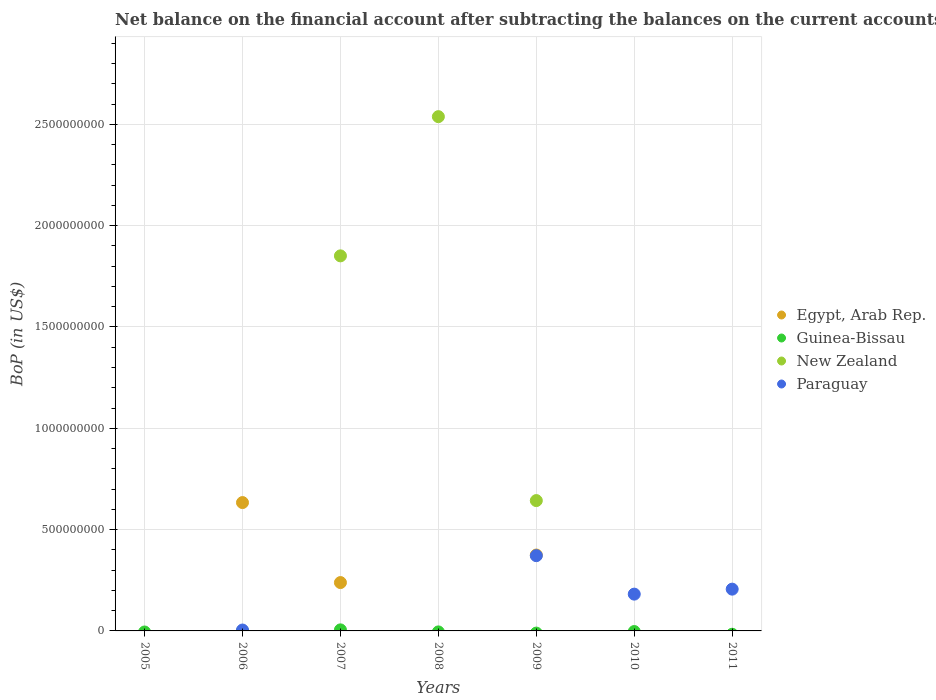Across all years, what is the maximum Balance of Payments in New Zealand?
Your answer should be very brief. 2.54e+09. Across all years, what is the minimum Balance of Payments in New Zealand?
Ensure brevity in your answer.  0. What is the total Balance of Payments in New Zealand in the graph?
Give a very brief answer. 5.03e+09. What is the difference between the Balance of Payments in Paraguay in 2006 and that in 2011?
Your answer should be compact. -2.02e+08. What is the difference between the Balance of Payments in Egypt, Arab Rep. in 2009 and the Balance of Payments in Paraguay in 2008?
Provide a short and direct response. 3.75e+08. What is the average Balance of Payments in New Zealand per year?
Make the answer very short. 7.19e+08. In the year 2007, what is the difference between the Balance of Payments in New Zealand and Balance of Payments in Guinea-Bissau?
Make the answer very short. 1.85e+09. In how many years, is the Balance of Payments in Paraguay greater than 2500000000 US$?
Ensure brevity in your answer.  0. What is the ratio of the Balance of Payments in Paraguay in 2009 to that in 2011?
Offer a terse response. 1.8. Is the Balance of Payments in Paraguay in 2010 less than that in 2011?
Provide a succinct answer. Yes. What is the difference between the highest and the second highest Balance of Payments in New Zealand?
Offer a terse response. 6.87e+08. What is the difference between the highest and the lowest Balance of Payments in Egypt, Arab Rep.?
Provide a short and direct response. 6.33e+08. Is it the case that in every year, the sum of the Balance of Payments in New Zealand and Balance of Payments in Egypt, Arab Rep.  is greater than the sum of Balance of Payments in Guinea-Bissau and Balance of Payments in Paraguay?
Your response must be concise. No. Is the Balance of Payments in New Zealand strictly less than the Balance of Payments in Paraguay over the years?
Keep it short and to the point. No. How many dotlines are there?
Keep it short and to the point. 4. How many years are there in the graph?
Offer a terse response. 7. Does the graph contain any zero values?
Offer a very short reply. Yes. How many legend labels are there?
Offer a terse response. 4. What is the title of the graph?
Make the answer very short. Net balance on the financial account after subtracting the balances on the current accounts. What is the label or title of the Y-axis?
Give a very brief answer. BoP (in US$). What is the BoP (in US$) in Egypt, Arab Rep. in 2006?
Offer a terse response. 6.33e+08. What is the BoP (in US$) of Paraguay in 2006?
Keep it short and to the point. 4.40e+06. What is the BoP (in US$) in Egypt, Arab Rep. in 2007?
Ensure brevity in your answer.  2.39e+08. What is the BoP (in US$) of Guinea-Bissau in 2007?
Keep it short and to the point. 5.20e+06. What is the BoP (in US$) of New Zealand in 2007?
Ensure brevity in your answer.  1.85e+09. What is the BoP (in US$) of Guinea-Bissau in 2008?
Offer a terse response. 0. What is the BoP (in US$) in New Zealand in 2008?
Provide a short and direct response. 2.54e+09. What is the BoP (in US$) of Egypt, Arab Rep. in 2009?
Your response must be concise. 3.75e+08. What is the BoP (in US$) in New Zealand in 2009?
Ensure brevity in your answer.  6.43e+08. What is the BoP (in US$) in Paraguay in 2009?
Provide a succinct answer. 3.71e+08. What is the BoP (in US$) in Guinea-Bissau in 2010?
Provide a short and direct response. 0. What is the BoP (in US$) in New Zealand in 2010?
Offer a very short reply. 0. What is the BoP (in US$) of Paraguay in 2010?
Your answer should be very brief. 1.82e+08. What is the BoP (in US$) of Egypt, Arab Rep. in 2011?
Offer a terse response. 0. What is the BoP (in US$) in Guinea-Bissau in 2011?
Offer a terse response. 0. What is the BoP (in US$) of Paraguay in 2011?
Offer a very short reply. 2.06e+08. Across all years, what is the maximum BoP (in US$) in Egypt, Arab Rep.?
Offer a terse response. 6.33e+08. Across all years, what is the maximum BoP (in US$) in Guinea-Bissau?
Your response must be concise. 5.20e+06. Across all years, what is the maximum BoP (in US$) in New Zealand?
Your answer should be very brief. 2.54e+09. Across all years, what is the maximum BoP (in US$) in Paraguay?
Provide a succinct answer. 3.71e+08. Across all years, what is the minimum BoP (in US$) of Guinea-Bissau?
Offer a very short reply. 0. What is the total BoP (in US$) in Egypt, Arab Rep. in the graph?
Give a very brief answer. 1.25e+09. What is the total BoP (in US$) of Guinea-Bissau in the graph?
Offer a terse response. 5.20e+06. What is the total BoP (in US$) of New Zealand in the graph?
Offer a very short reply. 5.03e+09. What is the total BoP (in US$) of Paraguay in the graph?
Provide a succinct answer. 7.64e+08. What is the difference between the BoP (in US$) of Egypt, Arab Rep. in 2006 and that in 2007?
Ensure brevity in your answer.  3.95e+08. What is the difference between the BoP (in US$) of Egypt, Arab Rep. in 2006 and that in 2009?
Provide a succinct answer. 2.59e+08. What is the difference between the BoP (in US$) of Paraguay in 2006 and that in 2009?
Provide a short and direct response. -3.67e+08. What is the difference between the BoP (in US$) in Paraguay in 2006 and that in 2010?
Give a very brief answer. -1.77e+08. What is the difference between the BoP (in US$) in Paraguay in 2006 and that in 2011?
Make the answer very short. -2.02e+08. What is the difference between the BoP (in US$) of New Zealand in 2007 and that in 2008?
Provide a succinct answer. -6.87e+08. What is the difference between the BoP (in US$) of Egypt, Arab Rep. in 2007 and that in 2009?
Your answer should be compact. -1.36e+08. What is the difference between the BoP (in US$) of New Zealand in 2007 and that in 2009?
Keep it short and to the point. 1.21e+09. What is the difference between the BoP (in US$) of New Zealand in 2008 and that in 2009?
Ensure brevity in your answer.  1.89e+09. What is the difference between the BoP (in US$) of Paraguay in 2009 and that in 2010?
Your answer should be very brief. 1.90e+08. What is the difference between the BoP (in US$) in Paraguay in 2009 and that in 2011?
Provide a succinct answer. 1.65e+08. What is the difference between the BoP (in US$) of Paraguay in 2010 and that in 2011?
Your response must be concise. -2.46e+07. What is the difference between the BoP (in US$) of Egypt, Arab Rep. in 2006 and the BoP (in US$) of Guinea-Bissau in 2007?
Offer a very short reply. 6.28e+08. What is the difference between the BoP (in US$) of Egypt, Arab Rep. in 2006 and the BoP (in US$) of New Zealand in 2007?
Your answer should be compact. -1.22e+09. What is the difference between the BoP (in US$) of Egypt, Arab Rep. in 2006 and the BoP (in US$) of New Zealand in 2008?
Offer a terse response. -1.90e+09. What is the difference between the BoP (in US$) in Egypt, Arab Rep. in 2006 and the BoP (in US$) in New Zealand in 2009?
Give a very brief answer. -9.81e+06. What is the difference between the BoP (in US$) of Egypt, Arab Rep. in 2006 and the BoP (in US$) of Paraguay in 2009?
Provide a short and direct response. 2.62e+08. What is the difference between the BoP (in US$) of Egypt, Arab Rep. in 2006 and the BoP (in US$) of Paraguay in 2010?
Your response must be concise. 4.52e+08. What is the difference between the BoP (in US$) of Egypt, Arab Rep. in 2006 and the BoP (in US$) of Paraguay in 2011?
Offer a terse response. 4.27e+08. What is the difference between the BoP (in US$) of Egypt, Arab Rep. in 2007 and the BoP (in US$) of New Zealand in 2008?
Keep it short and to the point. -2.30e+09. What is the difference between the BoP (in US$) in Guinea-Bissau in 2007 and the BoP (in US$) in New Zealand in 2008?
Keep it short and to the point. -2.53e+09. What is the difference between the BoP (in US$) in Egypt, Arab Rep. in 2007 and the BoP (in US$) in New Zealand in 2009?
Your answer should be very brief. -4.05e+08. What is the difference between the BoP (in US$) of Egypt, Arab Rep. in 2007 and the BoP (in US$) of Paraguay in 2009?
Your answer should be compact. -1.33e+08. What is the difference between the BoP (in US$) in Guinea-Bissau in 2007 and the BoP (in US$) in New Zealand in 2009?
Make the answer very short. -6.38e+08. What is the difference between the BoP (in US$) of Guinea-Bissau in 2007 and the BoP (in US$) of Paraguay in 2009?
Ensure brevity in your answer.  -3.66e+08. What is the difference between the BoP (in US$) in New Zealand in 2007 and the BoP (in US$) in Paraguay in 2009?
Provide a short and direct response. 1.48e+09. What is the difference between the BoP (in US$) in Egypt, Arab Rep. in 2007 and the BoP (in US$) in Paraguay in 2010?
Provide a succinct answer. 5.70e+07. What is the difference between the BoP (in US$) of Guinea-Bissau in 2007 and the BoP (in US$) of Paraguay in 2010?
Provide a short and direct response. -1.76e+08. What is the difference between the BoP (in US$) of New Zealand in 2007 and the BoP (in US$) of Paraguay in 2010?
Ensure brevity in your answer.  1.67e+09. What is the difference between the BoP (in US$) in Egypt, Arab Rep. in 2007 and the BoP (in US$) in Paraguay in 2011?
Offer a terse response. 3.24e+07. What is the difference between the BoP (in US$) of Guinea-Bissau in 2007 and the BoP (in US$) of Paraguay in 2011?
Offer a very short reply. -2.01e+08. What is the difference between the BoP (in US$) in New Zealand in 2007 and the BoP (in US$) in Paraguay in 2011?
Your response must be concise. 1.64e+09. What is the difference between the BoP (in US$) in New Zealand in 2008 and the BoP (in US$) in Paraguay in 2009?
Provide a short and direct response. 2.17e+09. What is the difference between the BoP (in US$) in New Zealand in 2008 and the BoP (in US$) in Paraguay in 2010?
Provide a short and direct response. 2.36e+09. What is the difference between the BoP (in US$) of New Zealand in 2008 and the BoP (in US$) of Paraguay in 2011?
Provide a succinct answer. 2.33e+09. What is the difference between the BoP (in US$) of Egypt, Arab Rep. in 2009 and the BoP (in US$) of Paraguay in 2010?
Your response must be concise. 1.93e+08. What is the difference between the BoP (in US$) in New Zealand in 2009 and the BoP (in US$) in Paraguay in 2010?
Provide a succinct answer. 4.62e+08. What is the difference between the BoP (in US$) of Egypt, Arab Rep. in 2009 and the BoP (in US$) of Paraguay in 2011?
Provide a short and direct response. 1.68e+08. What is the difference between the BoP (in US$) of New Zealand in 2009 and the BoP (in US$) of Paraguay in 2011?
Offer a terse response. 4.37e+08. What is the average BoP (in US$) in Egypt, Arab Rep. per year?
Provide a succinct answer. 1.78e+08. What is the average BoP (in US$) in Guinea-Bissau per year?
Make the answer very short. 7.43e+05. What is the average BoP (in US$) of New Zealand per year?
Provide a succinct answer. 7.19e+08. What is the average BoP (in US$) of Paraguay per year?
Your response must be concise. 1.09e+08. In the year 2006, what is the difference between the BoP (in US$) in Egypt, Arab Rep. and BoP (in US$) in Paraguay?
Give a very brief answer. 6.29e+08. In the year 2007, what is the difference between the BoP (in US$) in Egypt, Arab Rep. and BoP (in US$) in Guinea-Bissau?
Your answer should be very brief. 2.33e+08. In the year 2007, what is the difference between the BoP (in US$) of Egypt, Arab Rep. and BoP (in US$) of New Zealand?
Provide a short and direct response. -1.61e+09. In the year 2007, what is the difference between the BoP (in US$) of Guinea-Bissau and BoP (in US$) of New Zealand?
Your answer should be compact. -1.85e+09. In the year 2009, what is the difference between the BoP (in US$) of Egypt, Arab Rep. and BoP (in US$) of New Zealand?
Keep it short and to the point. -2.69e+08. In the year 2009, what is the difference between the BoP (in US$) of Egypt, Arab Rep. and BoP (in US$) of Paraguay?
Your response must be concise. 3.22e+06. In the year 2009, what is the difference between the BoP (in US$) of New Zealand and BoP (in US$) of Paraguay?
Make the answer very short. 2.72e+08. What is the ratio of the BoP (in US$) in Egypt, Arab Rep. in 2006 to that in 2007?
Your answer should be very brief. 2.65. What is the ratio of the BoP (in US$) of Egypt, Arab Rep. in 2006 to that in 2009?
Your response must be concise. 1.69. What is the ratio of the BoP (in US$) of Paraguay in 2006 to that in 2009?
Your response must be concise. 0.01. What is the ratio of the BoP (in US$) in Paraguay in 2006 to that in 2010?
Offer a terse response. 0.02. What is the ratio of the BoP (in US$) in Paraguay in 2006 to that in 2011?
Your response must be concise. 0.02. What is the ratio of the BoP (in US$) of New Zealand in 2007 to that in 2008?
Keep it short and to the point. 0.73. What is the ratio of the BoP (in US$) of Egypt, Arab Rep. in 2007 to that in 2009?
Offer a terse response. 0.64. What is the ratio of the BoP (in US$) of New Zealand in 2007 to that in 2009?
Keep it short and to the point. 2.88. What is the ratio of the BoP (in US$) of New Zealand in 2008 to that in 2009?
Your answer should be compact. 3.95. What is the ratio of the BoP (in US$) of Paraguay in 2009 to that in 2010?
Provide a short and direct response. 2.05. What is the ratio of the BoP (in US$) in Paraguay in 2009 to that in 2011?
Provide a succinct answer. 1.8. What is the ratio of the BoP (in US$) in Paraguay in 2010 to that in 2011?
Your answer should be very brief. 0.88. What is the difference between the highest and the second highest BoP (in US$) in Egypt, Arab Rep.?
Your answer should be very brief. 2.59e+08. What is the difference between the highest and the second highest BoP (in US$) in New Zealand?
Offer a very short reply. 6.87e+08. What is the difference between the highest and the second highest BoP (in US$) in Paraguay?
Keep it short and to the point. 1.65e+08. What is the difference between the highest and the lowest BoP (in US$) of Egypt, Arab Rep.?
Make the answer very short. 6.33e+08. What is the difference between the highest and the lowest BoP (in US$) of Guinea-Bissau?
Keep it short and to the point. 5.20e+06. What is the difference between the highest and the lowest BoP (in US$) of New Zealand?
Make the answer very short. 2.54e+09. What is the difference between the highest and the lowest BoP (in US$) in Paraguay?
Offer a terse response. 3.71e+08. 